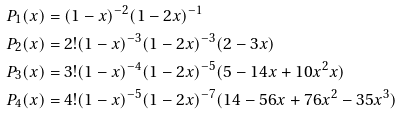<formula> <loc_0><loc_0><loc_500><loc_500>P _ { 1 } ( x ) & = ( 1 - x ) ^ { - 2 } ( 1 - 2 x ) ^ { - 1 } \\ P _ { 2 } ( x ) & = 2 ! ( 1 - x ) ^ { - 3 } ( 1 - 2 x ) ^ { - 3 } ( 2 - 3 x ) \\ P _ { 3 } ( x ) & = 3 ! ( 1 - x ) ^ { - 4 } ( 1 - 2 x ) ^ { - 5 } ( 5 - 1 4 x + 1 0 x ^ { 2 } x ) \\ P _ { 4 } ( x ) & = 4 ! ( 1 - x ) ^ { - 5 } ( 1 - 2 x ) ^ { - 7 } ( 1 4 - 5 6 x + 7 6 x ^ { 2 } - 3 5 x ^ { 3 } )</formula> 